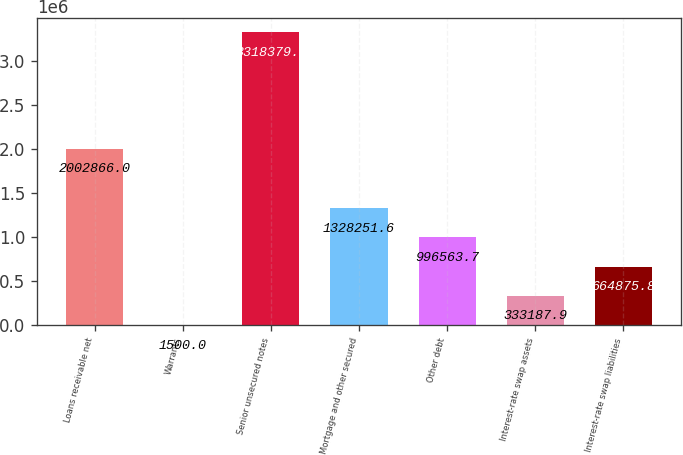Convert chart. <chart><loc_0><loc_0><loc_500><loc_500><bar_chart><fcel>Loans receivable net<fcel>Warrants<fcel>Senior unsecured notes<fcel>Mortgage and other secured<fcel>Other debt<fcel>Interest-rate swap assets<fcel>Interest-rate swap liabilities<nl><fcel>2.00287e+06<fcel>1500<fcel>3.31838e+06<fcel>1.32825e+06<fcel>996564<fcel>333188<fcel>664876<nl></chart> 